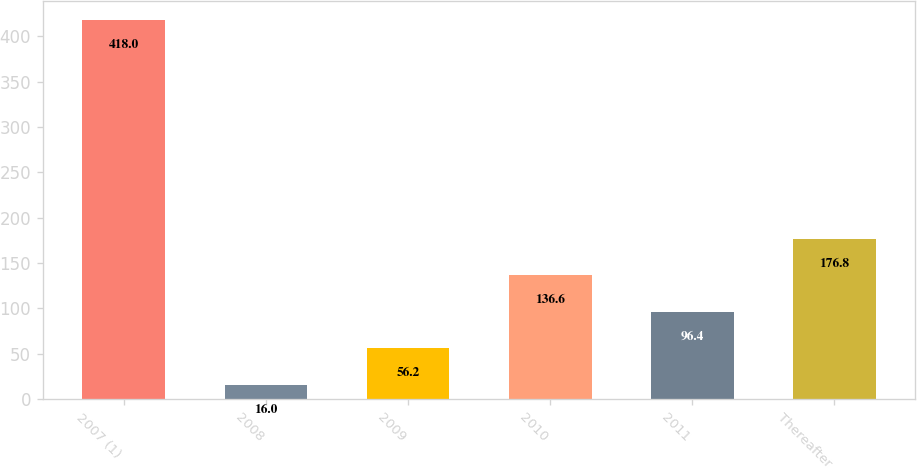Convert chart to OTSL. <chart><loc_0><loc_0><loc_500><loc_500><bar_chart><fcel>2007 (1)<fcel>2008<fcel>2009<fcel>2010<fcel>2011<fcel>Thereafter<nl><fcel>418<fcel>16<fcel>56.2<fcel>136.6<fcel>96.4<fcel>176.8<nl></chart> 